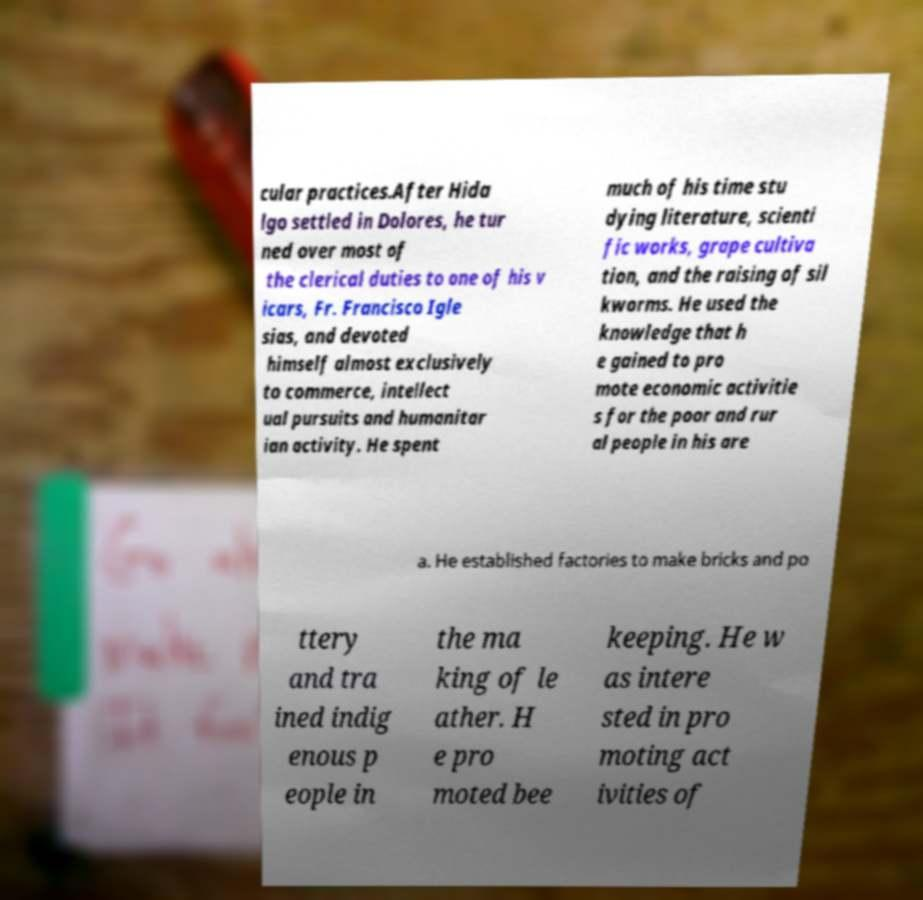What messages or text are displayed in this image? I need them in a readable, typed format. cular practices.After Hida lgo settled in Dolores, he tur ned over most of the clerical duties to one of his v icars, Fr. Francisco Igle sias, and devoted himself almost exclusively to commerce, intellect ual pursuits and humanitar ian activity. He spent much of his time stu dying literature, scienti fic works, grape cultiva tion, and the raising of sil kworms. He used the knowledge that h e gained to pro mote economic activitie s for the poor and rur al people in his are a. He established factories to make bricks and po ttery and tra ined indig enous p eople in the ma king of le ather. H e pro moted bee keeping. He w as intere sted in pro moting act ivities of 